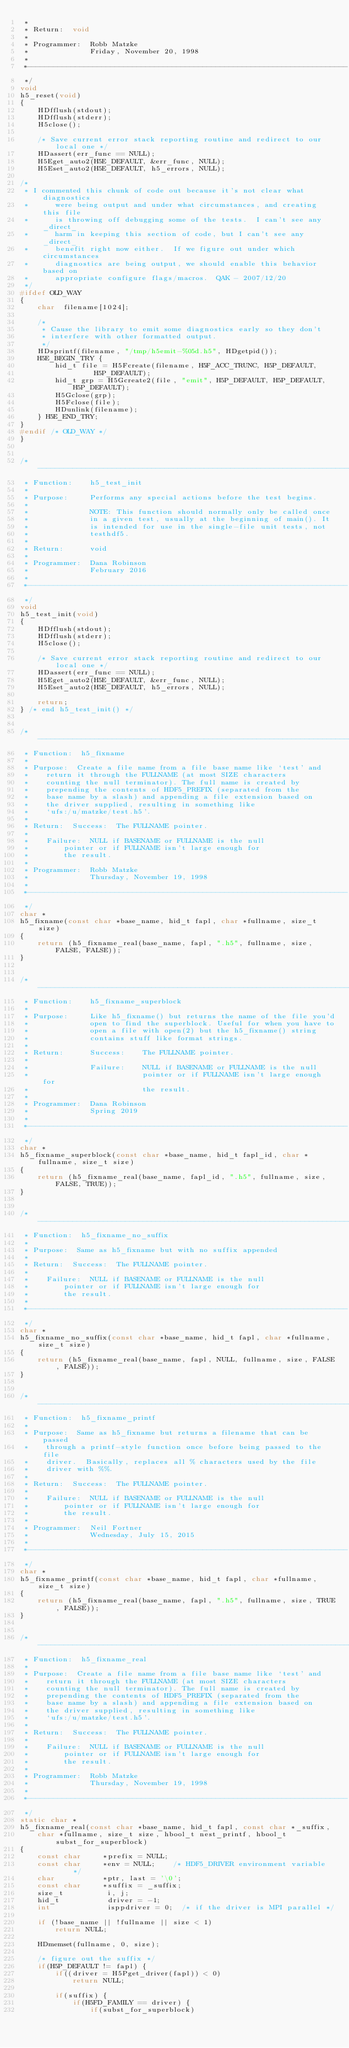<code> <loc_0><loc_0><loc_500><loc_500><_C_> *
 * Return:  void
 *
 * Programmer:  Robb Matzke
 *              Friday, November 20, 1998
 *
 *-------------------------------------------------------------------------
 */
void
h5_reset(void)
{
    HDfflush(stdout);
    HDfflush(stderr);
    H5close();

    /* Save current error stack reporting routine and redirect to our local one */
    HDassert(err_func == NULL);
    H5Eget_auto2(H5E_DEFAULT, &err_func, NULL);
    H5Eset_auto2(H5E_DEFAULT, h5_errors, NULL);

/*
 * I commented this chunk of code out because it's not clear what diagnostics
 *      were being output and under what circumstances, and creating this file
 *      is throwing off debugging some of the tests.  I can't see any _direct_
 *      harm in keeping this section of code, but I can't see any _direct_
 *      benefit right now either.  If we figure out under which circumstances
 *      diagnostics are being output, we should enable this behavior based on
 *      appropriate configure flags/macros.  QAK - 2007/12/20
 */
#ifdef OLD_WAY
{
    char  filename[1024];

    /*
     * Cause the library to emit some diagnostics early so they don't
     * interfere with other formatted output.
     */
    HDsprintf(filename, "/tmp/h5emit-%05d.h5", HDgetpid());
    H5E_BEGIN_TRY {
        hid_t file = H5Fcreate(filename, H5F_ACC_TRUNC, H5P_DEFAULT,
                 H5P_DEFAULT);
        hid_t grp = H5Gcreate2(file, "emit", H5P_DEFAULT, H5P_DEFAULT, H5P_DEFAULT);
        H5Gclose(grp);
        H5Fclose(file);
        HDunlink(filename);
    } H5E_END_TRY;
}
#endif /* OLD_WAY */
}


/*-------------------------------------------------------------------------
 * Function:    h5_test_init
 *
 * Purpose:     Performs any special actions before the test begins.
 *
 *              NOTE: This function should normally only be called once
 *              in a given test, usually at the beginning of main(). It
 *              is intended for use in the single-file unit tests, not
 *              testhdf5.
 *
 * Return:      void
 *
 * Programmer:  Dana Robinson
 *              February 2016
 *
 *-------------------------------------------------------------------------
 */
void
h5_test_init(void)
{
    HDfflush(stdout);
    HDfflush(stderr);
    H5close();

    /* Save current error stack reporting routine and redirect to our local one */
    HDassert(err_func == NULL);
    H5Eget_auto2(H5E_DEFAULT, &err_func, NULL);
    H5Eset_auto2(H5E_DEFAULT, h5_errors, NULL);

    return;
} /* end h5_test_init() */


/*-------------------------------------------------------------------------
 * Function:  h5_fixname
 *
 * Purpose:  Create a file name from a file base name like `test' and
 *    return it through the FULLNAME (at most SIZE characters
 *    counting the null terminator). The full name is created by
 *    prepending the contents of HDF5_PREFIX (separated from the
 *    base name by a slash) and appending a file extension based on
 *    the driver supplied, resulting in something like
 *    `ufs:/u/matzke/test.h5'.
 *
 * Return:  Success:  The FULLNAME pointer.
 *
 *    Failure:  NULL if BASENAME or FULLNAME is the null
 *        pointer or if FULLNAME isn't large enough for
 *        the result.
 *
 * Programmer:  Robb Matzke
 *              Thursday, November 19, 1998
 *
 *-------------------------------------------------------------------------
 */
char *
h5_fixname(const char *base_name, hid_t fapl, char *fullname, size_t size)
{
    return (h5_fixname_real(base_name, fapl, ".h5", fullname, size, FALSE, FALSE));
}


/*-------------------------------------------------------------------------
 * Function:    h5_fixname_superblock
 *
 * Purpose:     Like h5_fixname() but returns the name of the file you'd
 *              open to find the superblock. Useful for when you have to
 *              open a file with open(2) but the h5_fixname() string
 *              contains stuff like format strings.
 *
 * Return:      Success:    The FULLNAME pointer.
 *
 *              Failure:    NULL if BASENAME or FULLNAME is the null
 *                          pointer or if FULLNAME isn't large enough for
 *                          the result.
 *
 * Programmer:  Dana Robinson
 *              Spring 2019
 *
 *-------------------------------------------------------------------------
 */
char *
h5_fixname_superblock(const char *base_name, hid_t fapl_id, char *fullname, size_t size)
{
    return (h5_fixname_real(base_name, fapl_id, ".h5", fullname, size, FALSE, TRUE));
}


/*-------------------------------------------------------------------------
 * Function:  h5_fixname_no_suffix
 *
 * Purpose:  Same as h5_fixname but with no suffix appended
 *
 * Return:  Success:  The FULLNAME pointer.
 *
 *    Failure:  NULL if BASENAME or FULLNAME is the null
 *        pointer or if FULLNAME isn't large enough for
 *        the result.
 *
 *-------------------------------------------------------------------------
 */
char *
h5_fixname_no_suffix(const char *base_name, hid_t fapl, char *fullname, size_t size)
{
    return (h5_fixname_real(base_name, fapl, NULL, fullname, size, FALSE, FALSE));
}


/*-------------------------------------------------------------------------
 * Function:  h5_fixname_printf
 *
 * Purpose:  Same as h5_fixname but returns a filename that can be passed
 *    through a printf-style function once before being passed to the file
 *    driver.  Basically, replaces all % characters used by the file
 *    driver with %%.
 *
 * Return:  Success:  The FULLNAME pointer.
 *
 *    Failure:  NULL if BASENAME or FULLNAME is the null
 *        pointer or if FULLNAME isn't large enough for
 *        the result.
 *
 * Programmer:  Neil Fortner
 *              Wednesday, July 15, 2015
 *
 *-------------------------------------------------------------------------
 */
char *
h5_fixname_printf(const char *base_name, hid_t fapl, char *fullname, size_t size)
{
    return (h5_fixname_real(base_name, fapl, ".h5", fullname, size, TRUE, FALSE));
}


/*-------------------------------------------------------------------------
 * Function:  h5_fixname_real
 *
 * Purpose:  Create a file name from a file base name like `test' and
 *    return it through the FULLNAME (at most SIZE characters
 *    counting the null terminator). The full name is created by
 *    prepending the contents of HDF5_PREFIX (separated from the
 *    base name by a slash) and appending a file extension based on
 *    the driver supplied, resulting in something like
 *    `ufs:/u/matzke/test.h5'.
 *
 * Return:  Success:  The FULLNAME pointer.
 *
 *    Failure:  NULL if BASENAME or FULLNAME is the null
 *        pointer or if FULLNAME isn't large enough for
 *        the result.
 *
 * Programmer:  Robb Matzke
 *              Thursday, November 19, 1998
 *
 *-------------------------------------------------------------------------
 */
static char *
h5_fixname_real(const char *base_name, hid_t fapl, const char *_suffix,
    char *fullname, size_t size, hbool_t nest_printf, hbool_t subst_for_superblock)
{
    const char     *prefix = NULL;
    const char     *env = NULL;    /* HDF5_DRIVER environment variable     */
    char           *ptr, last = '\0';
    const char     *suffix = _suffix;
    size_t          i, j;
    hid_t           driver = -1;
    int             isppdriver = 0;  /* if the driver is MPI parallel */

    if (!base_name || !fullname || size < 1)
        return NULL;

    HDmemset(fullname, 0, size);

    /* figure out the suffix */
    if(H5P_DEFAULT != fapl) {
        if((driver = H5Pget_driver(fapl)) < 0)
            return NULL;

        if(suffix) {
            if(H5FD_FAMILY == driver) {
                if(subst_for_superblock)</code> 